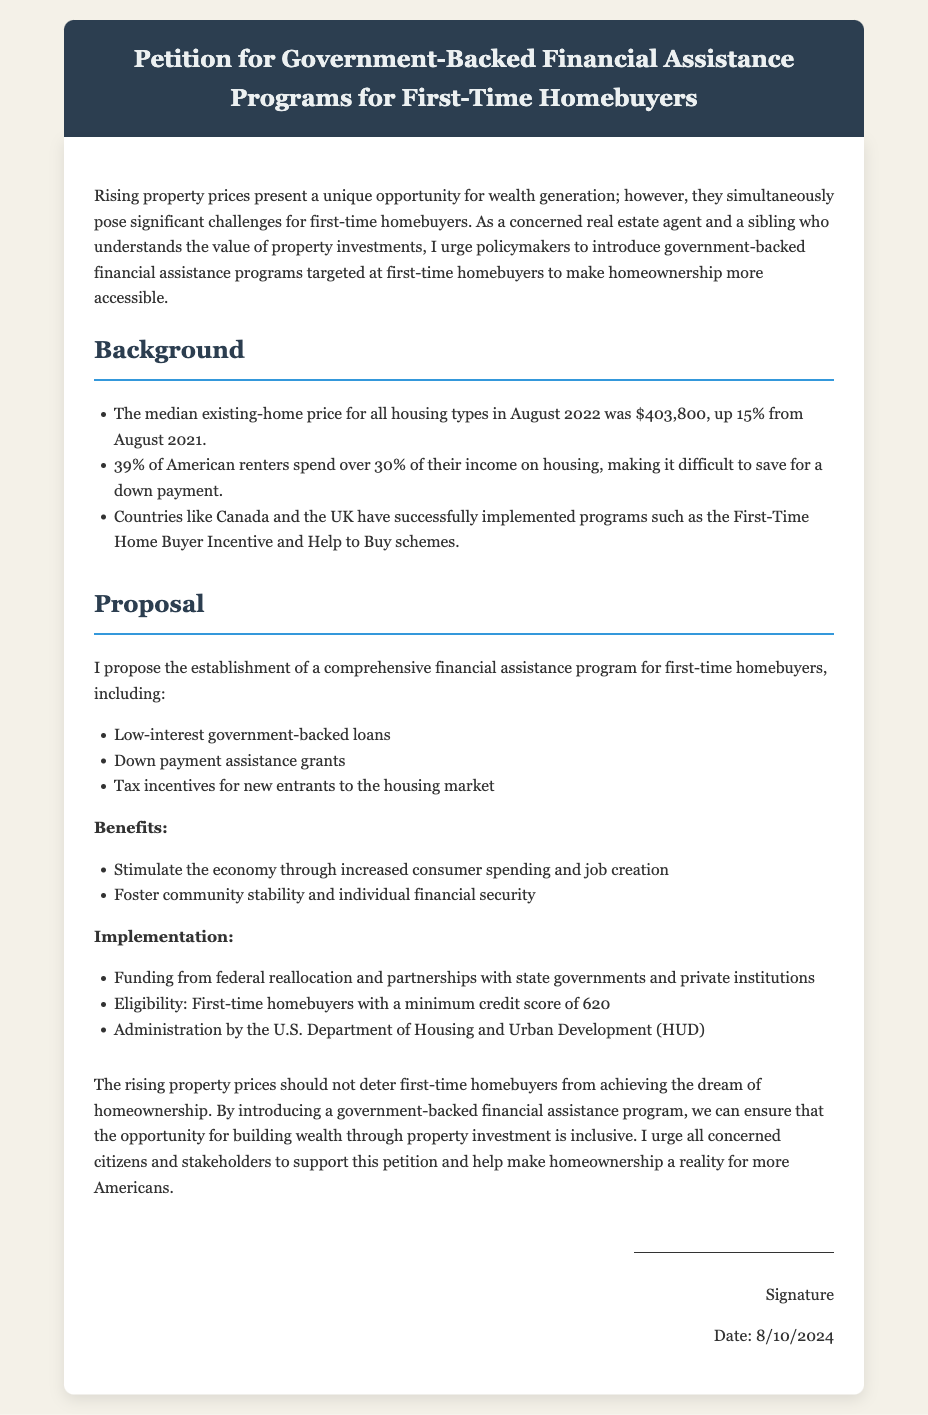what is the median existing-home price in August 2022? The median existing-home price for all housing types in August 2022 was $403,800.
Answer: $403,800 how much did the median price increase from August 2021? The document states that the price was up 15% from August 2021.
Answer: 15% what percentage of American renters spend over 30% of their income on housing? According to the document, 39% of American renters face this issue.
Answer: 39% what are two types of financial assistance proposed in the petition? The proposal includes low-interest government-backed loans and down payment assistance grants.
Answer: Low-interest government-backed loans, down payment assistance grants which government department would administer the proposed program? The document mentions that the U.S. Department of Housing and Urban Development (HUD) would be responsible for administration.
Answer: U.S. Department of Housing and Urban Development (HUD) what is one benefit of the proposed financial assistance program? The document lists stimulating the economy through increased consumer spending and job creation as a benefit.
Answer: Stimulate the economy through increased consumer spending and job creation who is the target audience for the proposed financial assistance program? The petition is aimed at first-time homebuyers.
Answer: First-time homebuyers what minimum credit score is mentioned for eligibility? The document states that the minimum credit score for eligibility is 620.
Answer: 620 